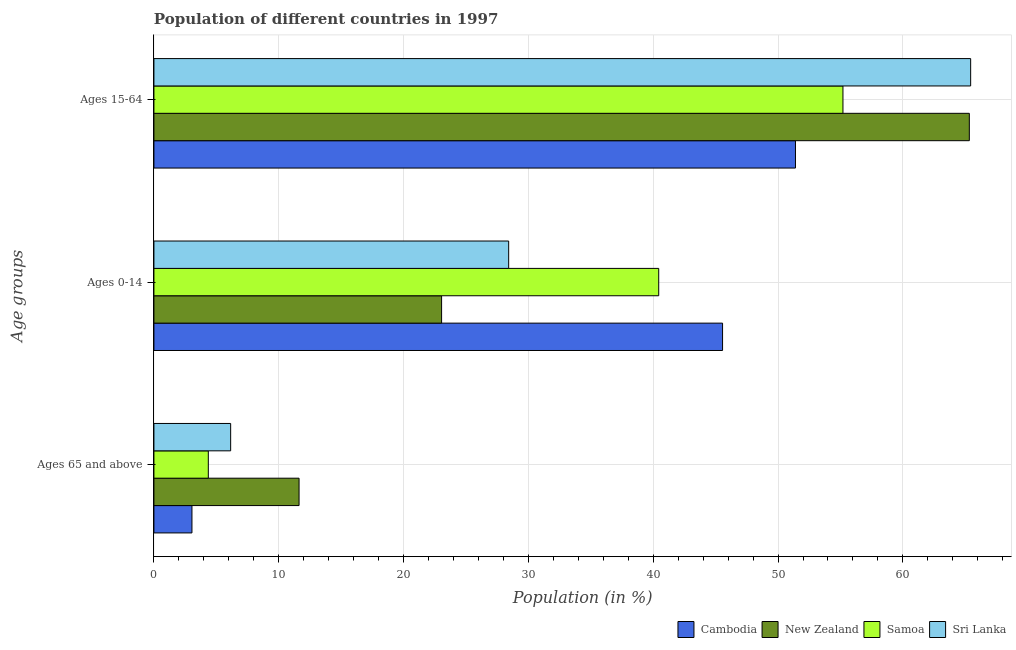How many different coloured bars are there?
Your answer should be compact. 4. How many bars are there on the 1st tick from the top?
Your answer should be very brief. 4. What is the label of the 3rd group of bars from the top?
Give a very brief answer. Ages 65 and above. What is the percentage of population within the age-group 15-64 in Sri Lanka?
Offer a terse response. 65.43. Across all countries, what is the maximum percentage of population within the age-group of 65 and above?
Keep it short and to the point. 11.63. Across all countries, what is the minimum percentage of population within the age-group of 65 and above?
Provide a short and direct response. 3.05. In which country was the percentage of population within the age-group 15-64 maximum?
Give a very brief answer. Sri Lanka. In which country was the percentage of population within the age-group 15-64 minimum?
Offer a terse response. Cambodia. What is the total percentage of population within the age-group 15-64 in the graph?
Offer a very short reply. 237.36. What is the difference between the percentage of population within the age-group 15-64 in New Zealand and that in Samoa?
Make the answer very short. 10.12. What is the difference between the percentage of population within the age-group 0-14 in Samoa and the percentage of population within the age-group of 65 and above in Sri Lanka?
Provide a succinct answer. 34.29. What is the average percentage of population within the age-group of 65 and above per country?
Make the answer very short. 6.29. What is the difference between the percentage of population within the age-group 15-64 and percentage of population within the age-group of 65 and above in New Zealand?
Your answer should be compact. 53.7. What is the ratio of the percentage of population within the age-group 0-14 in Sri Lanka to that in New Zealand?
Ensure brevity in your answer.  1.23. Is the percentage of population within the age-group 15-64 in Sri Lanka less than that in Samoa?
Offer a very short reply. No. What is the difference between the highest and the second highest percentage of population within the age-group 15-64?
Offer a terse response. 0.11. What is the difference between the highest and the lowest percentage of population within the age-group of 65 and above?
Your answer should be compact. 8.58. In how many countries, is the percentage of population within the age-group 15-64 greater than the average percentage of population within the age-group 15-64 taken over all countries?
Keep it short and to the point. 2. What does the 3rd bar from the top in Ages 0-14 represents?
Offer a terse response. New Zealand. What does the 4th bar from the bottom in Ages 15-64 represents?
Provide a succinct answer. Sri Lanka. Does the graph contain grids?
Keep it short and to the point. Yes. How many legend labels are there?
Your response must be concise. 4. How are the legend labels stacked?
Provide a short and direct response. Horizontal. What is the title of the graph?
Your response must be concise. Population of different countries in 1997. Does "Senegal" appear as one of the legend labels in the graph?
Offer a terse response. No. What is the label or title of the Y-axis?
Provide a short and direct response. Age groups. What is the Population (in %) in Cambodia in Ages 65 and above?
Your response must be concise. 3.05. What is the Population (in %) of New Zealand in Ages 65 and above?
Provide a succinct answer. 11.63. What is the Population (in %) of Samoa in Ages 65 and above?
Offer a very short reply. 4.36. What is the Population (in %) of Sri Lanka in Ages 65 and above?
Your response must be concise. 6.15. What is the Population (in %) of Cambodia in Ages 0-14?
Offer a very short reply. 45.56. What is the Population (in %) of New Zealand in Ages 0-14?
Give a very brief answer. 23.05. What is the Population (in %) of Samoa in Ages 0-14?
Your answer should be compact. 40.44. What is the Population (in %) of Sri Lanka in Ages 0-14?
Your answer should be compact. 28.42. What is the Population (in %) in Cambodia in Ages 15-64?
Provide a succinct answer. 51.4. What is the Population (in %) of New Zealand in Ages 15-64?
Offer a very short reply. 65.33. What is the Population (in %) in Samoa in Ages 15-64?
Your answer should be compact. 55.2. What is the Population (in %) of Sri Lanka in Ages 15-64?
Offer a very short reply. 65.43. Across all Age groups, what is the maximum Population (in %) of Cambodia?
Your answer should be very brief. 51.4. Across all Age groups, what is the maximum Population (in %) in New Zealand?
Your answer should be compact. 65.33. Across all Age groups, what is the maximum Population (in %) in Samoa?
Offer a terse response. 55.2. Across all Age groups, what is the maximum Population (in %) in Sri Lanka?
Make the answer very short. 65.43. Across all Age groups, what is the minimum Population (in %) in Cambodia?
Give a very brief answer. 3.05. Across all Age groups, what is the minimum Population (in %) in New Zealand?
Your answer should be compact. 11.63. Across all Age groups, what is the minimum Population (in %) of Samoa?
Offer a terse response. 4.36. Across all Age groups, what is the minimum Population (in %) of Sri Lanka?
Offer a terse response. 6.15. What is the total Population (in %) in Cambodia in the graph?
Your answer should be very brief. 100. What is the total Population (in %) of New Zealand in the graph?
Provide a succinct answer. 100. What is the difference between the Population (in %) in Cambodia in Ages 65 and above and that in Ages 0-14?
Offer a terse response. -42.51. What is the difference between the Population (in %) in New Zealand in Ages 65 and above and that in Ages 0-14?
Provide a short and direct response. -11.42. What is the difference between the Population (in %) of Samoa in Ages 65 and above and that in Ages 0-14?
Provide a succinct answer. -36.08. What is the difference between the Population (in %) of Sri Lanka in Ages 65 and above and that in Ages 0-14?
Your answer should be very brief. -22.27. What is the difference between the Population (in %) of Cambodia in Ages 65 and above and that in Ages 15-64?
Your answer should be compact. -48.35. What is the difference between the Population (in %) of New Zealand in Ages 65 and above and that in Ages 15-64?
Ensure brevity in your answer.  -53.7. What is the difference between the Population (in %) of Samoa in Ages 65 and above and that in Ages 15-64?
Ensure brevity in your answer.  -50.84. What is the difference between the Population (in %) of Sri Lanka in Ages 65 and above and that in Ages 15-64?
Your answer should be compact. -59.28. What is the difference between the Population (in %) of Cambodia in Ages 0-14 and that in Ages 15-64?
Offer a very short reply. -5.84. What is the difference between the Population (in %) of New Zealand in Ages 0-14 and that in Ages 15-64?
Offer a terse response. -42.28. What is the difference between the Population (in %) in Samoa in Ages 0-14 and that in Ages 15-64?
Your response must be concise. -14.76. What is the difference between the Population (in %) of Sri Lanka in Ages 0-14 and that in Ages 15-64?
Make the answer very short. -37.01. What is the difference between the Population (in %) of Cambodia in Ages 65 and above and the Population (in %) of New Zealand in Ages 0-14?
Your answer should be very brief. -20. What is the difference between the Population (in %) of Cambodia in Ages 65 and above and the Population (in %) of Samoa in Ages 0-14?
Provide a short and direct response. -37.4. What is the difference between the Population (in %) in Cambodia in Ages 65 and above and the Population (in %) in Sri Lanka in Ages 0-14?
Give a very brief answer. -25.37. What is the difference between the Population (in %) in New Zealand in Ages 65 and above and the Population (in %) in Samoa in Ages 0-14?
Your answer should be compact. -28.81. What is the difference between the Population (in %) in New Zealand in Ages 65 and above and the Population (in %) in Sri Lanka in Ages 0-14?
Offer a terse response. -16.79. What is the difference between the Population (in %) of Samoa in Ages 65 and above and the Population (in %) of Sri Lanka in Ages 0-14?
Ensure brevity in your answer.  -24.06. What is the difference between the Population (in %) in Cambodia in Ages 65 and above and the Population (in %) in New Zealand in Ages 15-64?
Ensure brevity in your answer.  -62.28. What is the difference between the Population (in %) of Cambodia in Ages 65 and above and the Population (in %) of Samoa in Ages 15-64?
Offer a very short reply. -52.16. What is the difference between the Population (in %) of Cambodia in Ages 65 and above and the Population (in %) of Sri Lanka in Ages 15-64?
Make the answer very short. -62.39. What is the difference between the Population (in %) in New Zealand in Ages 65 and above and the Population (in %) in Samoa in Ages 15-64?
Your answer should be very brief. -43.57. What is the difference between the Population (in %) in New Zealand in Ages 65 and above and the Population (in %) in Sri Lanka in Ages 15-64?
Your answer should be very brief. -53.8. What is the difference between the Population (in %) in Samoa in Ages 65 and above and the Population (in %) in Sri Lanka in Ages 15-64?
Offer a terse response. -61.08. What is the difference between the Population (in %) in Cambodia in Ages 0-14 and the Population (in %) in New Zealand in Ages 15-64?
Offer a very short reply. -19.77. What is the difference between the Population (in %) in Cambodia in Ages 0-14 and the Population (in %) in Samoa in Ages 15-64?
Your response must be concise. -9.65. What is the difference between the Population (in %) of Cambodia in Ages 0-14 and the Population (in %) of Sri Lanka in Ages 15-64?
Your response must be concise. -19.88. What is the difference between the Population (in %) of New Zealand in Ages 0-14 and the Population (in %) of Samoa in Ages 15-64?
Your answer should be very brief. -32.15. What is the difference between the Population (in %) in New Zealand in Ages 0-14 and the Population (in %) in Sri Lanka in Ages 15-64?
Offer a very short reply. -42.39. What is the difference between the Population (in %) of Samoa in Ages 0-14 and the Population (in %) of Sri Lanka in Ages 15-64?
Offer a very short reply. -24.99. What is the average Population (in %) of Cambodia per Age groups?
Provide a short and direct response. 33.33. What is the average Population (in %) in New Zealand per Age groups?
Your answer should be compact. 33.33. What is the average Population (in %) in Samoa per Age groups?
Ensure brevity in your answer.  33.33. What is the average Population (in %) of Sri Lanka per Age groups?
Your answer should be compact. 33.33. What is the difference between the Population (in %) in Cambodia and Population (in %) in New Zealand in Ages 65 and above?
Make the answer very short. -8.58. What is the difference between the Population (in %) of Cambodia and Population (in %) of Samoa in Ages 65 and above?
Offer a terse response. -1.31. What is the difference between the Population (in %) of Cambodia and Population (in %) of Sri Lanka in Ages 65 and above?
Your answer should be compact. -3.1. What is the difference between the Population (in %) in New Zealand and Population (in %) in Samoa in Ages 65 and above?
Provide a succinct answer. 7.27. What is the difference between the Population (in %) of New Zealand and Population (in %) of Sri Lanka in Ages 65 and above?
Ensure brevity in your answer.  5.48. What is the difference between the Population (in %) in Samoa and Population (in %) in Sri Lanka in Ages 65 and above?
Make the answer very short. -1.79. What is the difference between the Population (in %) in Cambodia and Population (in %) in New Zealand in Ages 0-14?
Your response must be concise. 22.51. What is the difference between the Population (in %) of Cambodia and Population (in %) of Samoa in Ages 0-14?
Your response must be concise. 5.11. What is the difference between the Population (in %) in Cambodia and Population (in %) in Sri Lanka in Ages 0-14?
Keep it short and to the point. 17.14. What is the difference between the Population (in %) in New Zealand and Population (in %) in Samoa in Ages 0-14?
Offer a terse response. -17.39. What is the difference between the Population (in %) of New Zealand and Population (in %) of Sri Lanka in Ages 0-14?
Ensure brevity in your answer.  -5.37. What is the difference between the Population (in %) of Samoa and Population (in %) of Sri Lanka in Ages 0-14?
Your answer should be compact. 12.02. What is the difference between the Population (in %) in Cambodia and Population (in %) in New Zealand in Ages 15-64?
Provide a succinct answer. -13.93. What is the difference between the Population (in %) in Cambodia and Population (in %) in Samoa in Ages 15-64?
Keep it short and to the point. -3.8. What is the difference between the Population (in %) of Cambodia and Population (in %) of Sri Lanka in Ages 15-64?
Offer a terse response. -14.03. What is the difference between the Population (in %) in New Zealand and Population (in %) in Samoa in Ages 15-64?
Offer a very short reply. 10.12. What is the difference between the Population (in %) of New Zealand and Population (in %) of Sri Lanka in Ages 15-64?
Offer a terse response. -0.11. What is the difference between the Population (in %) in Samoa and Population (in %) in Sri Lanka in Ages 15-64?
Your answer should be compact. -10.23. What is the ratio of the Population (in %) of Cambodia in Ages 65 and above to that in Ages 0-14?
Your answer should be compact. 0.07. What is the ratio of the Population (in %) of New Zealand in Ages 65 and above to that in Ages 0-14?
Ensure brevity in your answer.  0.5. What is the ratio of the Population (in %) of Samoa in Ages 65 and above to that in Ages 0-14?
Provide a short and direct response. 0.11. What is the ratio of the Population (in %) in Sri Lanka in Ages 65 and above to that in Ages 0-14?
Offer a terse response. 0.22. What is the ratio of the Population (in %) in Cambodia in Ages 65 and above to that in Ages 15-64?
Provide a short and direct response. 0.06. What is the ratio of the Population (in %) of New Zealand in Ages 65 and above to that in Ages 15-64?
Ensure brevity in your answer.  0.18. What is the ratio of the Population (in %) of Samoa in Ages 65 and above to that in Ages 15-64?
Your answer should be very brief. 0.08. What is the ratio of the Population (in %) of Sri Lanka in Ages 65 and above to that in Ages 15-64?
Give a very brief answer. 0.09. What is the ratio of the Population (in %) in Cambodia in Ages 0-14 to that in Ages 15-64?
Offer a terse response. 0.89. What is the ratio of the Population (in %) in New Zealand in Ages 0-14 to that in Ages 15-64?
Give a very brief answer. 0.35. What is the ratio of the Population (in %) in Samoa in Ages 0-14 to that in Ages 15-64?
Give a very brief answer. 0.73. What is the ratio of the Population (in %) in Sri Lanka in Ages 0-14 to that in Ages 15-64?
Offer a very short reply. 0.43. What is the difference between the highest and the second highest Population (in %) in Cambodia?
Keep it short and to the point. 5.84. What is the difference between the highest and the second highest Population (in %) of New Zealand?
Ensure brevity in your answer.  42.28. What is the difference between the highest and the second highest Population (in %) in Samoa?
Make the answer very short. 14.76. What is the difference between the highest and the second highest Population (in %) in Sri Lanka?
Offer a very short reply. 37.01. What is the difference between the highest and the lowest Population (in %) of Cambodia?
Offer a very short reply. 48.35. What is the difference between the highest and the lowest Population (in %) of New Zealand?
Provide a succinct answer. 53.7. What is the difference between the highest and the lowest Population (in %) of Samoa?
Provide a short and direct response. 50.84. What is the difference between the highest and the lowest Population (in %) of Sri Lanka?
Provide a succinct answer. 59.28. 